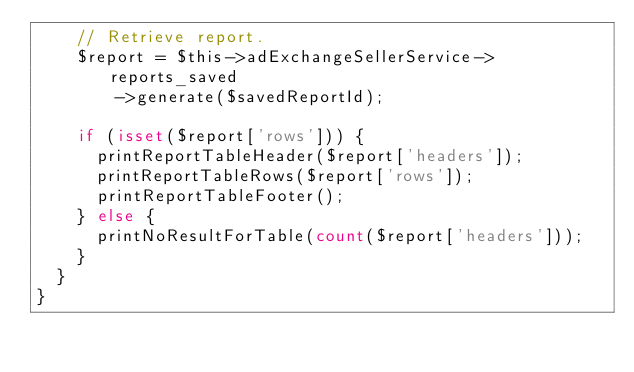<code> <loc_0><loc_0><loc_500><loc_500><_PHP_>    // Retrieve report.
    $report = $this->adExchangeSellerService->reports_saved
        ->generate($savedReportId);

    if (isset($report['rows'])) {
      printReportTableHeader($report['headers']);
      printReportTableRows($report['rows']);
      printReportTableFooter();
    } else {
      printNoResultForTable(count($report['headers']));
    }
  }
}

</code> 